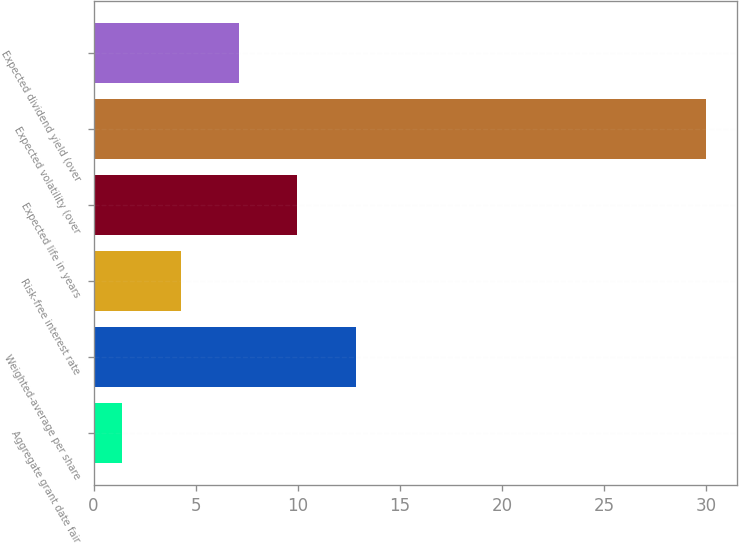<chart> <loc_0><loc_0><loc_500><loc_500><bar_chart><fcel>Aggregate grant date fair<fcel>Weighted-average per share<fcel>Risk-free interest rate<fcel>Expected life in years<fcel>Expected volatility (over<fcel>Expected dividend yield (over<nl><fcel>1.4<fcel>12.84<fcel>4.26<fcel>9.98<fcel>30<fcel>7.12<nl></chart> 